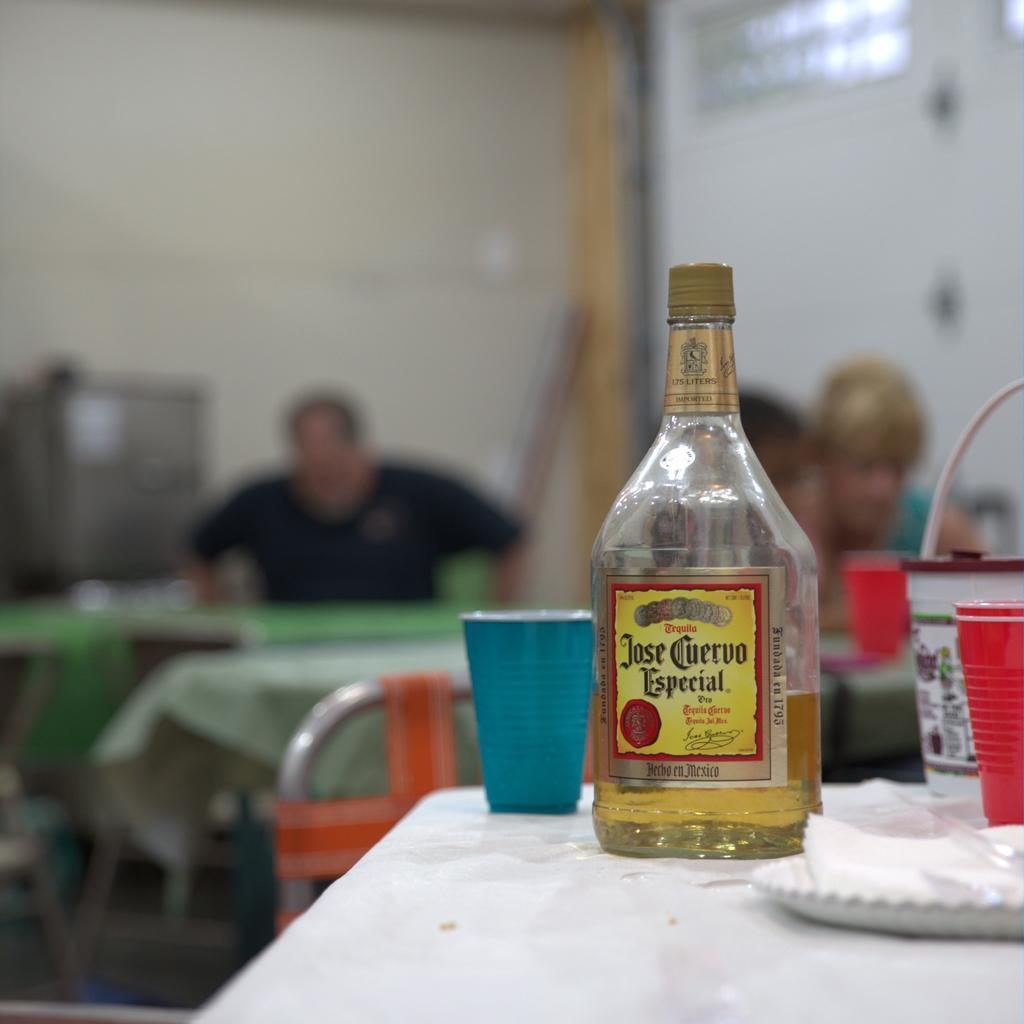Please provide a concise description of this image. In this picture we can see a table. On the table there are bottle, glass, and plates. This is chair. On the background we can see a man who is sitting on the chair. And this is wall. 